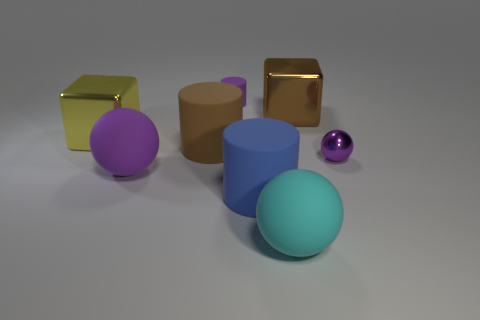Is there any other thing that has the same color as the tiny cylinder?
Keep it short and to the point. Yes. Are there any purple spheres that have the same material as the yellow block?
Provide a short and direct response. Yes. Does the big cylinder that is to the left of the small purple cylinder have the same material as the tiny cylinder?
Provide a succinct answer. Yes. How big is the purple thing that is both right of the big purple sphere and to the left of the small purple ball?
Offer a terse response. Small. What is the color of the tiny matte object?
Make the answer very short. Purple. How many purple shiny balls are there?
Your answer should be compact. 1. How many cylinders are the same color as the small ball?
Keep it short and to the point. 1. Does the purple matte object that is behind the tiny metallic thing have the same shape as the big brown object to the left of the blue rubber cylinder?
Offer a very short reply. Yes. There is a large metal thing that is right of the tiny thing behind the object right of the big brown cube; what is its color?
Provide a succinct answer. Brown. What is the color of the small thing that is to the right of the big brown shiny thing?
Provide a short and direct response. Purple. 